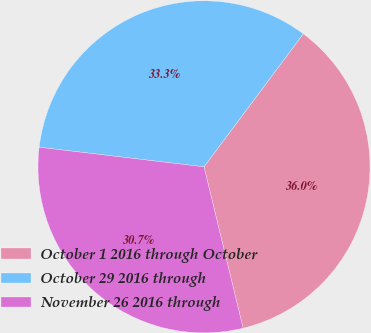<chart> <loc_0><loc_0><loc_500><loc_500><pie_chart><fcel>October 1 2016 through October<fcel>October 29 2016 through<fcel>November 26 2016 through<nl><fcel>36.01%<fcel>33.32%<fcel>30.67%<nl></chart> 